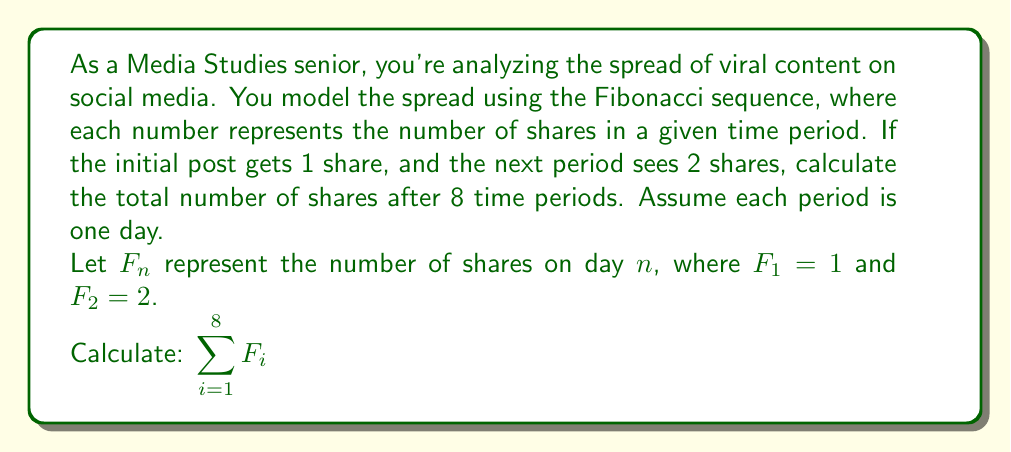Teach me how to tackle this problem. To solve this problem, we need to:
1. Generate the Fibonacci sequence for the first 8 terms
2. Sum up all these terms

Let's start by generating the sequence:

$F_1 = 1$
$F_2 = 2$
$F_3 = F_2 + F_1 = 2 + 1 = 3$
$F_4 = F_3 + F_2 = 3 + 2 = 5$
$F_5 = F_4 + F_3 = 5 + 3 = 8$
$F_6 = F_5 + F_4 = 8 + 5 = 13$
$F_7 = F_6 + F_5 = 13 + 8 = 21$
$F_8 = F_7 + F_6 = 21 + 13 = 34$

Now, we need to sum all these terms:

$$\sum_{i=1}^8 F_i = 1 + 2 + 3 + 5 + 8 + 13 + 21 + 34$$

Adding these numbers:

$$1 + 2 + 3 + 5 + 8 + 13 + 21 + 34 = 87$$

Therefore, the total number of shares after 8 time periods is 87.

This model demonstrates how viral content can spread exponentially, which is relevant to understanding content dissemination in social media and digital marketing strategies.
Answer: $\sum_{i=1}^8 F_i = 87$ shares 